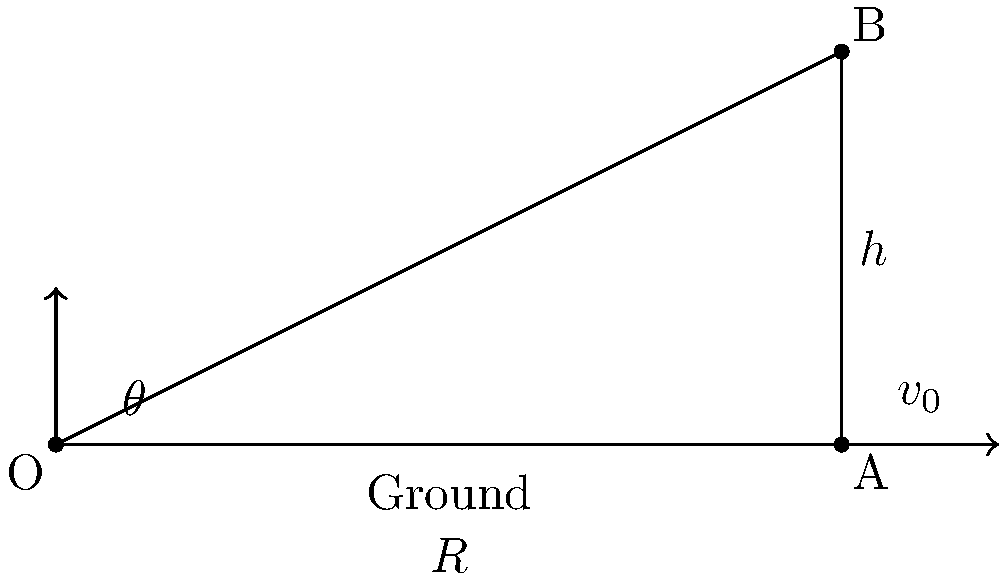As an environmental engineering student with a background in track and field, you're studying the physics of javelin throwing to optimize performance while considering energy efficiency. Given that the initial velocity of a javelin throw is $v_0 = 25$ m/s and the release height is $h = 2.5$ m, determine the optimal launch angle $\theta$ that will maximize the horizontal distance $R$ traveled by the javelin. Ignore air resistance and use $g = 9.8$ m/s² for acceleration due to gravity. To find the optimal launch angle for maximum horizontal distance, we'll follow these steps:

1) The general equation for the range $R$ of a projectile launched from height $h$ is:

   $$R = \frac{v_0^2}{2g}\left(\sin(2\theta) + \sqrt{\sin^2(2\theta) + \frac{4gh}{v_0^2}}\right)$$

2) To find the maximum range, we need to differentiate $R$ with respect to $\theta$ and set it to zero. However, this leads to a complex equation.

3) For launches from ground level ($h = 0$), the optimal angle is always 45°. With a non-zero launch height, the optimal angle is slightly less than 45°.

4) We can use the approximation:

   $$\theta_{optimal} \approx 45° - \frac{1}{2}\arcsin\left(\frac{gh}{v_0^2}\right)$$

5) Substituting our values:

   $$\theta_{optimal} \approx 45° - \frac{1}{2}\arcsin\left(\frac{9.8 \times 2.5}{25^2}\right)$$

6) Calculate:
   $$\theta_{optimal} \approx 45° - \frac{1}{2}\arcsin(0.0392)$$
   $$\theta_{optimal} \approx 45° - 0.5 \times 2.25°$$
   $$\theta_{optimal} \approx 43.88°$$

7) Round to the nearest degree: 44°

This angle will provide the maximum range, optimizing the javelin throw while considering the release height.
Answer: 44° 